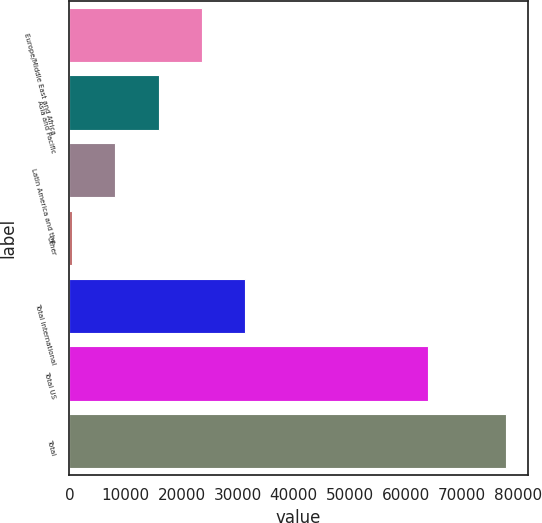<chart> <loc_0><loc_0><loc_500><loc_500><bar_chart><fcel>Europe/Middle East and Africa<fcel>Asia and Pacific<fcel>Latin America and the<fcel>Other<fcel>Total international<fcel>Total US<fcel>Total<nl><fcel>23639.6<fcel>15897.4<fcel>8155.2<fcel>413<fcel>31381.8<fcel>63981<fcel>77835<nl></chart> 